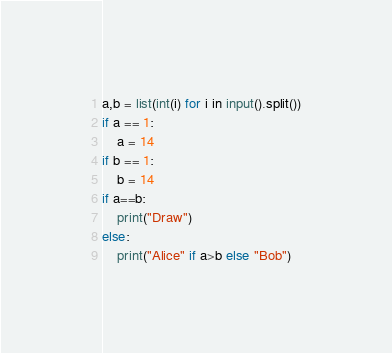Convert code to text. <code><loc_0><loc_0><loc_500><loc_500><_Python_>a,b = list(int(i) for i in input().split())
if a == 1:
    a = 14
if b == 1:
    b = 14
if a==b:
    print("Draw")
else:
    print("Alice" if a>b else "Bob")</code> 